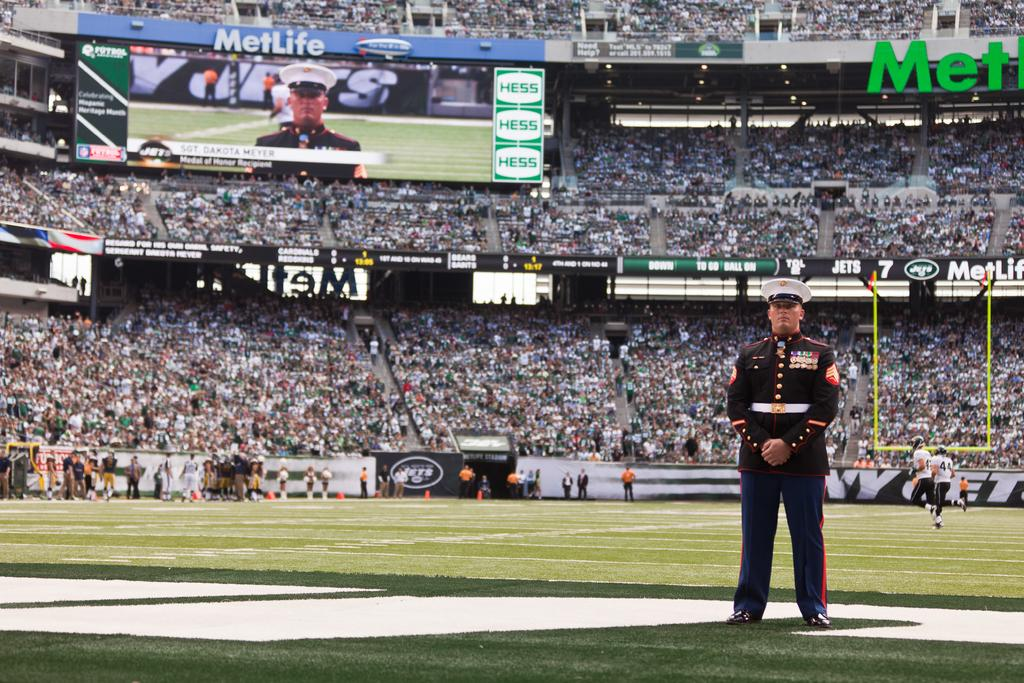<image>
Share a concise interpretation of the image provided. A Military Officer standing in the end zone at the New York Jets football stadium. 